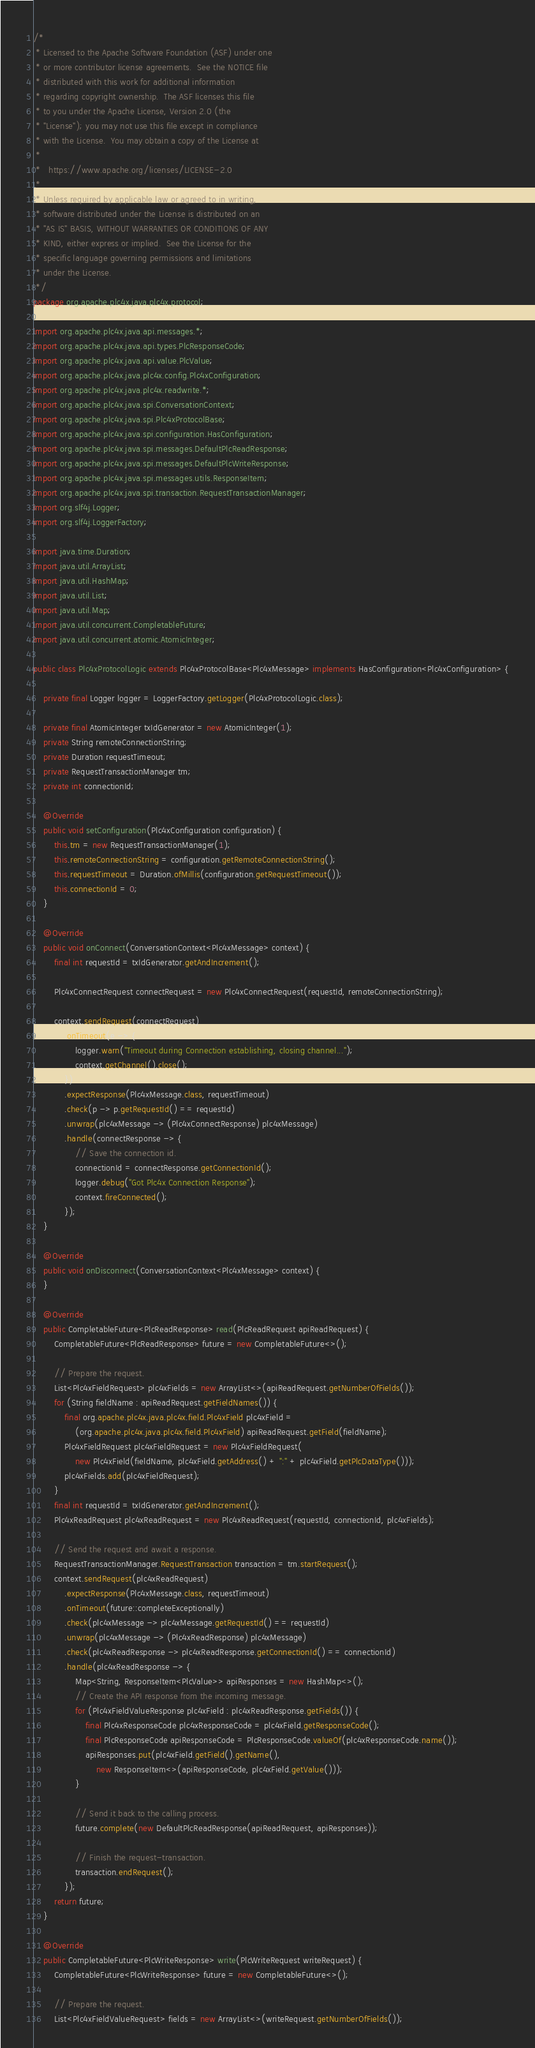<code> <loc_0><loc_0><loc_500><loc_500><_Java_>/*
 * Licensed to the Apache Software Foundation (ASF) under one
 * or more contributor license agreements.  See the NOTICE file
 * distributed with this work for additional information
 * regarding copyright ownership.  The ASF licenses this file
 * to you under the Apache License, Version 2.0 (the
 * "License"); you may not use this file except in compliance
 * with the License.  You may obtain a copy of the License at
 *
 *   https://www.apache.org/licenses/LICENSE-2.0
 *
 * Unless required by applicable law or agreed to in writing,
 * software distributed under the License is distributed on an
 * "AS IS" BASIS, WITHOUT WARRANTIES OR CONDITIONS OF ANY
 * KIND, either express or implied.  See the License for the
 * specific language governing permissions and limitations
 * under the License.
 */
package org.apache.plc4x.java.plc4x.protocol;

import org.apache.plc4x.java.api.messages.*;
import org.apache.plc4x.java.api.types.PlcResponseCode;
import org.apache.plc4x.java.api.value.PlcValue;
import org.apache.plc4x.java.plc4x.config.Plc4xConfiguration;
import org.apache.plc4x.java.plc4x.readwrite.*;
import org.apache.plc4x.java.spi.ConversationContext;
import org.apache.plc4x.java.spi.Plc4xProtocolBase;
import org.apache.plc4x.java.spi.configuration.HasConfiguration;
import org.apache.plc4x.java.spi.messages.DefaultPlcReadResponse;
import org.apache.plc4x.java.spi.messages.DefaultPlcWriteResponse;
import org.apache.plc4x.java.spi.messages.utils.ResponseItem;
import org.apache.plc4x.java.spi.transaction.RequestTransactionManager;
import org.slf4j.Logger;
import org.slf4j.LoggerFactory;

import java.time.Duration;
import java.util.ArrayList;
import java.util.HashMap;
import java.util.List;
import java.util.Map;
import java.util.concurrent.CompletableFuture;
import java.util.concurrent.atomic.AtomicInteger;

public class Plc4xProtocolLogic extends Plc4xProtocolBase<Plc4xMessage> implements HasConfiguration<Plc4xConfiguration> {

    private final Logger logger = LoggerFactory.getLogger(Plc4xProtocolLogic.class);

    private final AtomicInteger txIdGenerator = new AtomicInteger(1);
    private String remoteConnectionString;
    private Duration requestTimeout;
    private RequestTransactionManager tm;
    private int connectionId;

    @Override
    public void setConfiguration(Plc4xConfiguration configuration) {
        this.tm = new RequestTransactionManager(1);
        this.remoteConnectionString = configuration.getRemoteConnectionString();
        this.requestTimeout = Duration.ofMillis(configuration.getRequestTimeout());
        this.connectionId = 0;
    }

    @Override
    public void onConnect(ConversationContext<Plc4xMessage> context) {
        final int requestId = txIdGenerator.getAndIncrement();

        Plc4xConnectRequest connectRequest = new Plc4xConnectRequest(requestId, remoteConnectionString);

        context.sendRequest(connectRequest)
            .onTimeout(e -> {
                logger.warn("Timeout during Connection establishing, closing channel...");
                context.getChannel().close();
            })
            .expectResponse(Plc4xMessage.class, requestTimeout)
            .check(p -> p.getRequestId() == requestId)
            .unwrap(plc4xMessage -> (Plc4xConnectResponse) plc4xMessage)
            .handle(connectResponse -> {
                // Save the connection id.
                connectionId = connectResponse.getConnectionId();
                logger.debug("Got Plc4x Connection Response");
                context.fireConnected();
            });
    }

    @Override
    public void onDisconnect(ConversationContext<Plc4xMessage> context) {
    }

    @Override
    public CompletableFuture<PlcReadResponse> read(PlcReadRequest apiReadRequest) {
        CompletableFuture<PlcReadResponse> future = new CompletableFuture<>();

        // Prepare the request.
        List<Plc4xFieldRequest> plc4xFields = new ArrayList<>(apiReadRequest.getNumberOfFields());
        for (String fieldName : apiReadRequest.getFieldNames()) {
            final org.apache.plc4x.java.plc4x.field.Plc4xField plc4xField =
                (org.apache.plc4x.java.plc4x.field.Plc4xField) apiReadRequest.getField(fieldName);
            Plc4xFieldRequest plc4xFieldRequest = new Plc4xFieldRequest(
                new Plc4xField(fieldName, plc4xField.getAddress() + ":" + plc4xField.getPlcDataType()));
            plc4xFields.add(plc4xFieldRequest);
        }
        final int requestId = txIdGenerator.getAndIncrement();
        Plc4xReadRequest plc4xReadRequest = new Plc4xReadRequest(requestId, connectionId, plc4xFields);

        // Send the request and await a response.
        RequestTransactionManager.RequestTransaction transaction = tm.startRequest();
        context.sendRequest(plc4xReadRequest)
            .expectResponse(Plc4xMessage.class, requestTimeout)
            .onTimeout(future::completeExceptionally)
            .check(plc4xMessage -> plc4xMessage.getRequestId() == requestId)
            .unwrap(plc4xMessage -> (Plc4xReadResponse) plc4xMessage)
            .check(plc4xReadResponse -> plc4xReadResponse.getConnectionId() == connectionId)
            .handle(plc4xReadResponse -> {
                Map<String, ResponseItem<PlcValue>> apiResponses = new HashMap<>();
                // Create the API response from the incoming message.
                for (Plc4xFieldValueResponse plc4xField : plc4xReadResponse.getFields()) {
                    final Plc4xResponseCode plc4xResponseCode = plc4xField.getResponseCode();
                    final PlcResponseCode apiResponseCode = PlcResponseCode.valueOf(plc4xResponseCode.name());
                    apiResponses.put(plc4xField.getField().getName(),
                        new ResponseItem<>(apiResponseCode, plc4xField.getValue()));
                }

                // Send it back to the calling process.
                future.complete(new DefaultPlcReadResponse(apiReadRequest, apiResponses));

                // Finish the request-transaction.
                transaction.endRequest();
            });
        return future;
    }

    @Override
    public CompletableFuture<PlcWriteResponse> write(PlcWriteRequest writeRequest) {
        CompletableFuture<PlcWriteResponse> future = new CompletableFuture<>();

        // Prepare the request.
        List<Plc4xFieldValueRequest> fields = new ArrayList<>(writeRequest.getNumberOfFields());</code> 